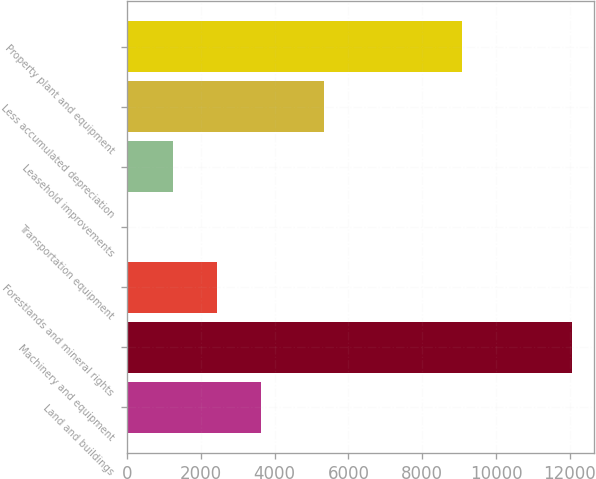Convert chart. <chart><loc_0><loc_0><loc_500><loc_500><bar_chart><fcel>Land and buildings<fcel>Machinery and equipment<fcel>Forestlands and mineral rights<fcel>Transportation equipment<fcel>Leasehold improvements<fcel>Less accumulated depreciation<fcel>Property plant and equipment<nl><fcel>3640.27<fcel>12064<fcel>2436.88<fcel>30.1<fcel>1233.49<fcel>5337.4<fcel>9082.5<nl></chart> 